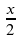<formula> <loc_0><loc_0><loc_500><loc_500>\frac { x } { 2 }</formula> 